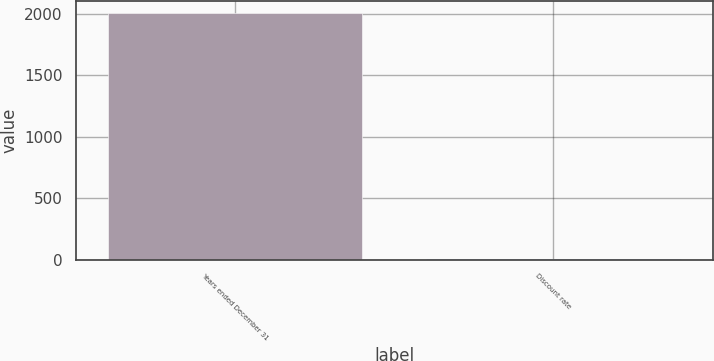<chart> <loc_0><loc_0><loc_500><loc_500><bar_chart><fcel>Years ended December 31<fcel>Discount rate<nl><fcel>2005<fcel>5.41<nl></chart> 